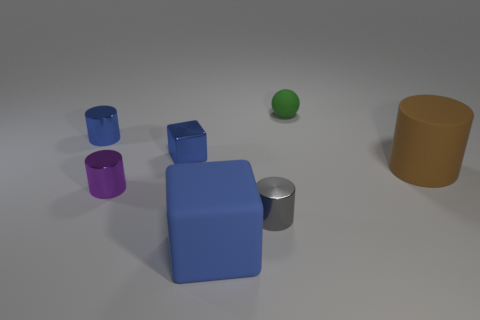Add 3 gray metal cylinders. How many objects exist? 10 Subtract all spheres. How many objects are left? 6 Add 3 large gray metallic blocks. How many large gray metallic blocks exist? 3 Subtract 1 green balls. How many objects are left? 6 Subtract all big cyan blocks. Subtract all large cylinders. How many objects are left? 6 Add 2 small green matte balls. How many small green matte balls are left? 3 